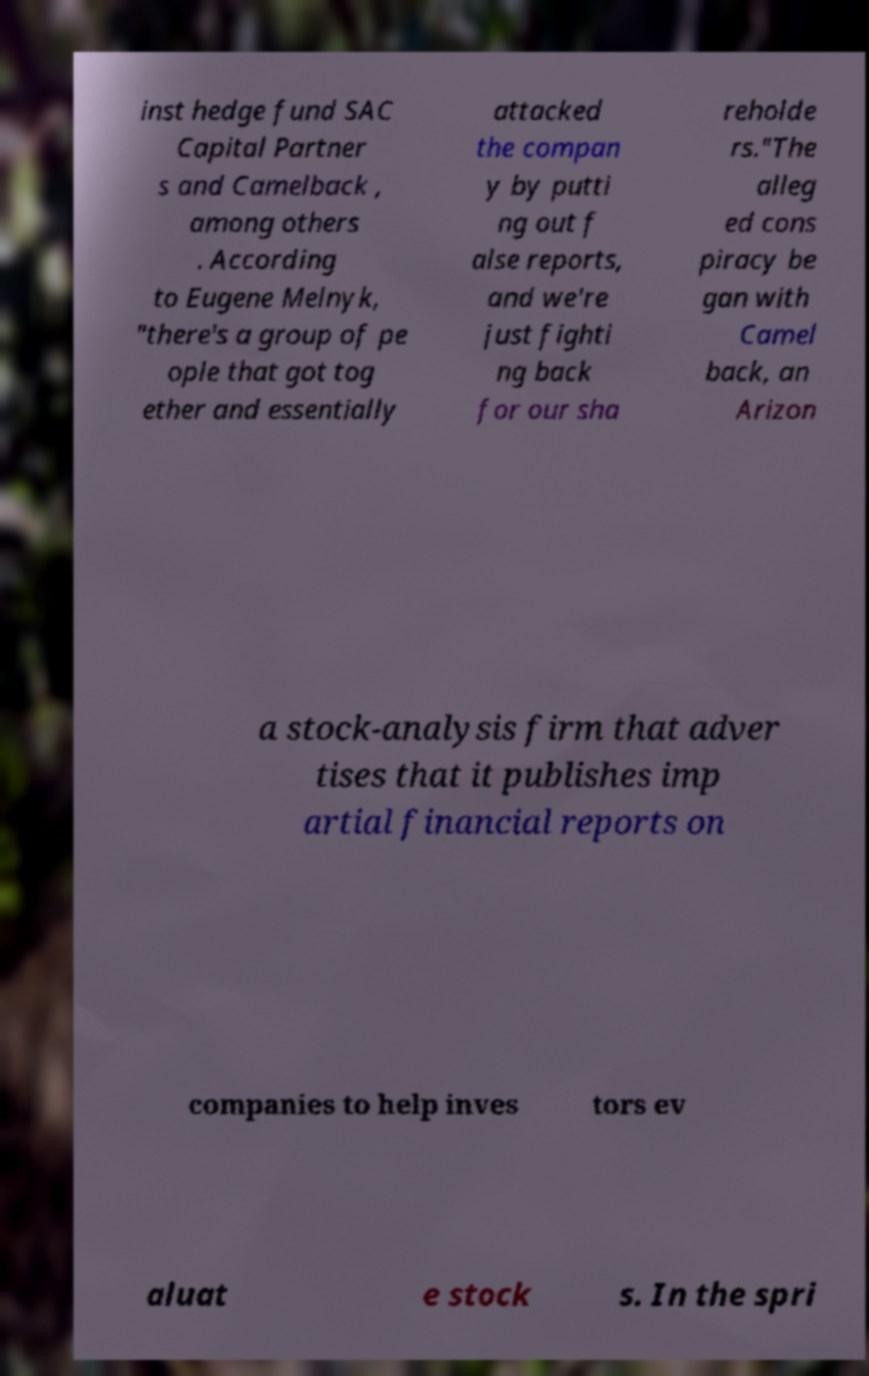There's text embedded in this image that I need extracted. Can you transcribe it verbatim? inst hedge fund SAC Capital Partner s and Camelback , among others . According to Eugene Melnyk, "there's a group of pe ople that got tog ether and essentially attacked the compan y by putti ng out f alse reports, and we're just fighti ng back for our sha reholde rs."The alleg ed cons piracy be gan with Camel back, an Arizon a stock-analysis firm that adver tises that it publishes imp artial financial reports on companies to help inves tors ev aluat e stock s. In the spri 